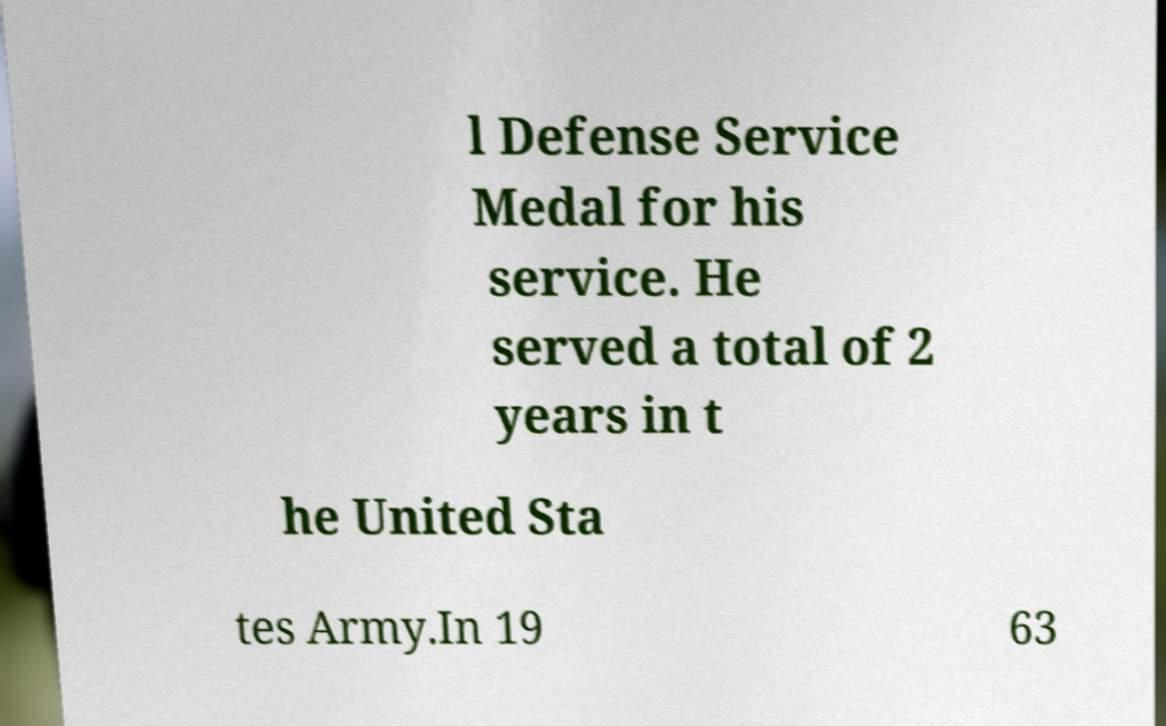Can you accurately transcribe the text from the provided image for me? l Defense Service Medal for his service. He served a total of 2 years in t he United Sta tes Army.In 19 63 